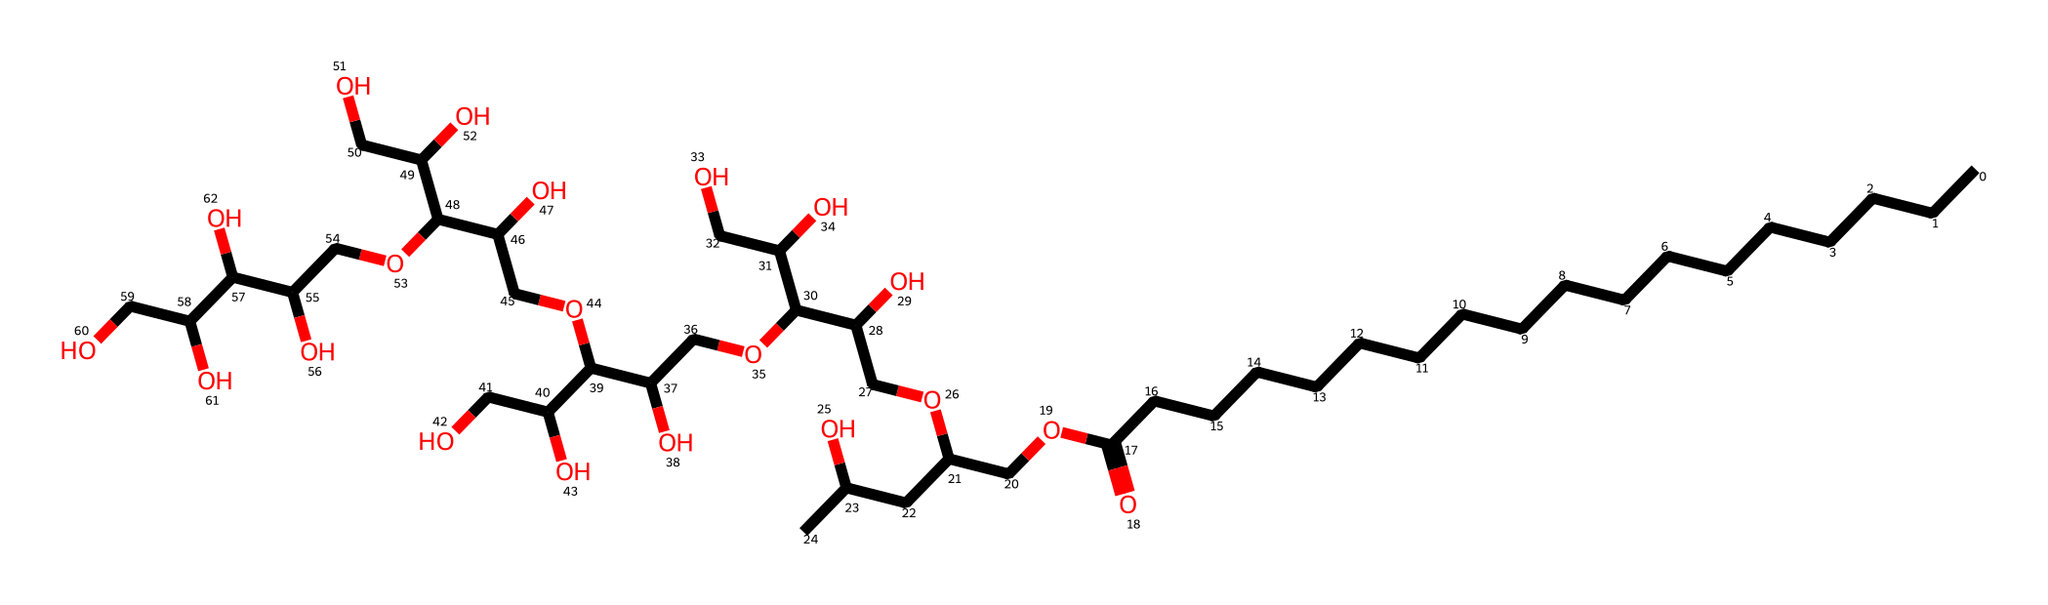What is the main carbon chain length in polysorbate 20? The main carbon chain consists of 20 carbon atoms, as indicated by the presence of "CCCCCCCCCCCCCCCCCC" in the SMILES representation.
Answer: 20 How many hydroxyl (–OH) groups are present in this chemical? By analyzing the structure, there are four terminal –OH groups, so in total there are five –OH groups, taking into account the multiple –OH functionalities present in the side chains.
Answer: 5 What type of emulsifier is polysorbate 20 classified as? Polysorbate 20 is classified as a non-ionic surfactant due to the presence of polyoxyethylene units and no ionic charge in the structure.
Answer: non-ionic Which functional groups are prominently featured in polysorbate 20? The prominent functional groups include esters (due to the fatty acid moiety) and alcohols (hydroxyl groups from –OH).
Answer: esters and alcohols What role does the hydrophilic part of polysorbate 20 play in emulsification? The hydrophilic part, comprised of the polyoxyethylene groups, allows for interactions with water, promoting the stabilization of the emulsion by reducing the surface tension between oil and water phases.
Answer: stabilization of emulsion How many side chains are connected to the main carbon chain in polysorbate 20? Referring to the structure, there are multiple side chains connected; specifically, there are five significant carbon-centered branched side chains extending from the main chain.
Answer: 5 